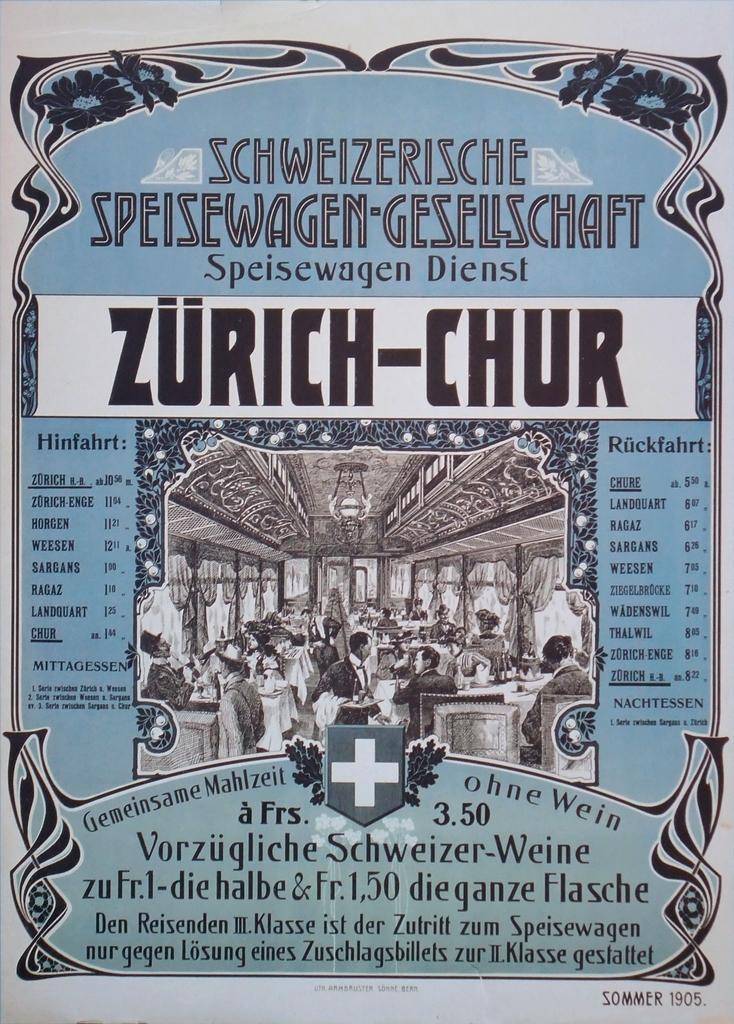What is the name on this poster?
Offer a terse response. Zurich-chur. 